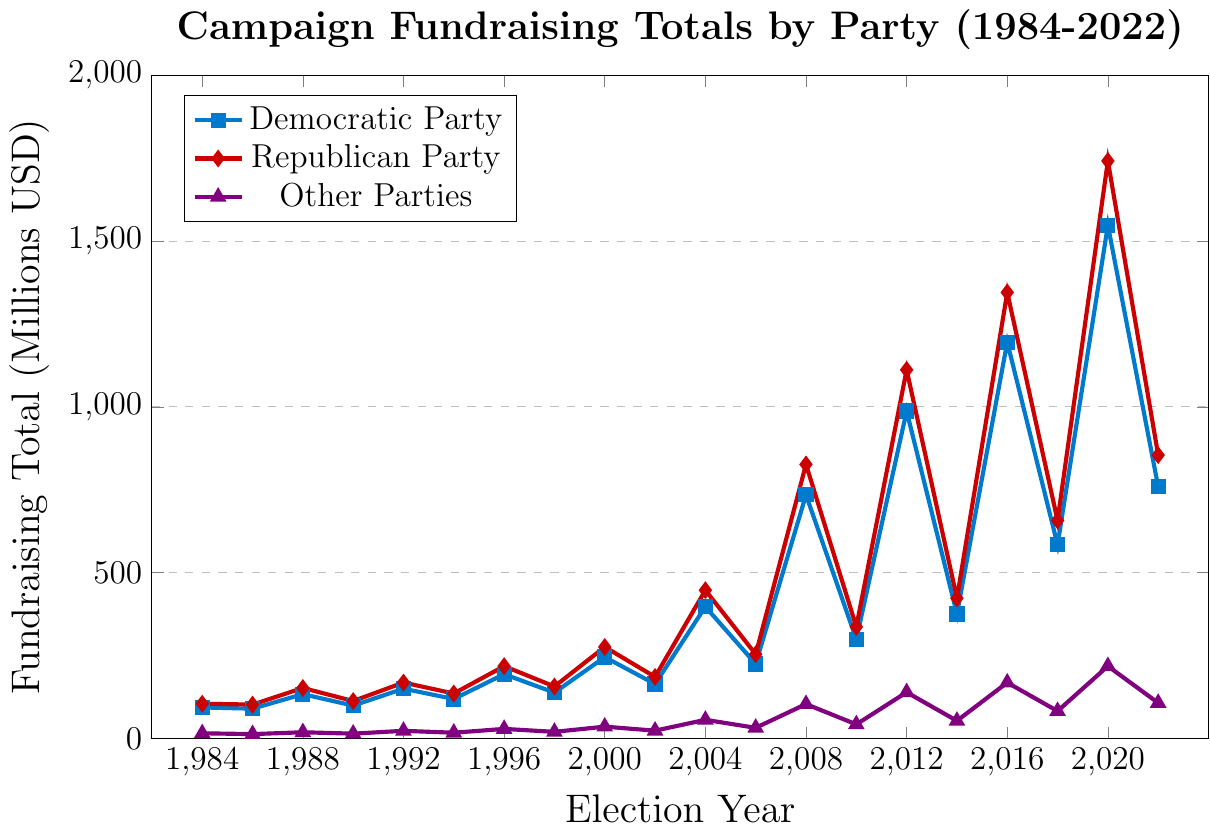What's the largest difference in fundraising totals between the Democratic and Republican Parties in any election year? First, identify the fundraising totals for both parties in each year. The largest difference occurs in 2020, where the Republican Party raised 1742.1 million, and the Democratic Party raised 1547.8 million. Calculate the difference: 1742.1 - 1547.8 = 194.3 million.
Answer: 194.3 million Which party had the highest fundraising total in 2012? In 2012, the Democratic Party raised 987.3 million, while the Republican Party raised 1111.7 million, and Other Parties raised 139.0 million. The Republican Party has the highest total.
Answer: Republican Party In which year did Other Parties raise the most money? By visually inspecting the line for Other Parties (purple), it reaches its peak in 2020 at 217.8 million.
Answer: 2020 During which election years did the Democratic Party raise more than the Republican Party? Look at the fundraising totals for each year and compare. In 1984, 2008, and 2018, the Democratic Party raised more than the Republican Party.
Answer: 1984, 2008, 2018 What is the average fundraising total for the Democratic Party over all the presented election cycles? Sum all the totals for the Democratic Party from 1984 to 2022 and divide by the number of election cycles (20). (93.1 + 89.5 + 133.2 + 98.7 + 149.8 + 118.6 + 193.5 + 137.9 + 245.1 + 163.8 + 397.2 + 224.5 + 734.6 + 298.7 + 987.3 + 375.2 + 1195.4 + 583.9 + 1547.8 + 759.1) / 20 = 9335.9 / 20 = 466.795 million.
Answer: 466.8 million By how much did the fundraising totals for Other Parties increase from 2008 to 2012? In 2008, Other Parties raised 103.3 million. In 2012, they raised 139.0 million. The increase is 139.0 - 103.3 = 35.7 million.
Answer: 35.7 million What trend do you observe in the Republican Party’s fundraising totals from 1984 to 2022? Visually, the Republican Party’s fundraising totals generally increase over time, with notable spikes in cycles such as 2008, 2012, 2016, and 2020.
Answer: Increasing trend with spikes Are there any election years where the combined total of all parties was higher than 2000 million? Calculate the combined totals for each year and check. The only year where the combined total exceeds 2000 million is 2020 with 3507.7 million (1547.8 + 1742.1 + 217.8).
Answer: Yes, 2020 